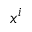<formula> <loc_0><loc_0><loc_500><loc_500>x ^ { i }</formula> 